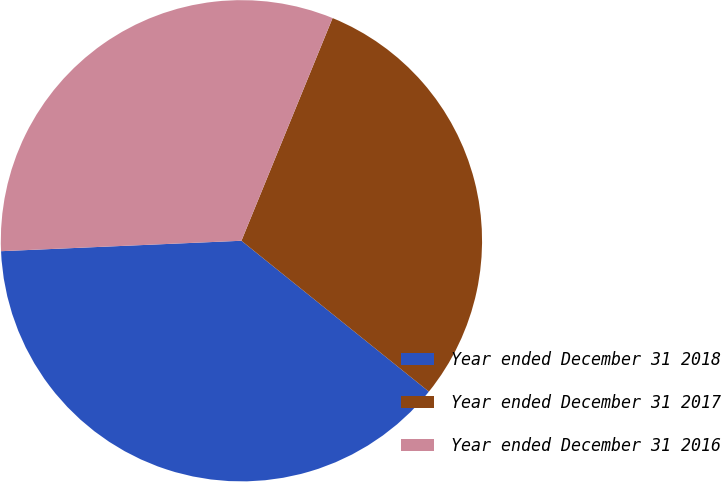Convert chart. <chart><loc_0><loc_0><loc_500><loc_500><pie_chart><fcel>Year ended December 31 2018<fcel>Year ended December 31 2017<fcel>Year ended December 31 2016<nl><fcel>38.52%<fcel>29.6%<fcel>31.87%<nl></chart> 